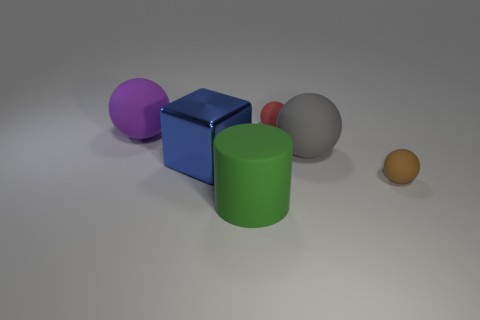Is the number of large purple rubber balls behind the blue cube less than the number of big green rubber cylinders?
Provide a succinct answer. No. There is a gray object that is the same material as the purple sphere; what is its shape?
Provide a succinct answer. Sphere. Do the tiny red ball and the brown thing have the same material?
Provide a short and direct response. Yes. Are there fewer big purple matte balls that are behind the purple rubber sphere than spheres behind the cylinder?
Provide a succinct answer. Yes. There is a small matte ball that is behind the rubber sphere in front of the blue metallic object; how many brown matte balls are in front of it?
Provide a short and direct response. 1. There is another matte sphere that is the same size as the brown matte sphere; what is its color?
Your response must be concise. Red. Are there any small gray things that have the same shape as the big blue shiny thing?
Your answer should be compact. No. There is a small sphere that is right of the red matte ball behind the gray rubber thing; are there any gray spheres that are behind it?
Your response must be concise. Yes. What is the shape of the green rubber thing that is the same size as the blue metal object?
Provide a short and direct response. Cylinder. The other big thing that is the same shape as the large gray matte object is what color?
Your response must be concise. Purple. 